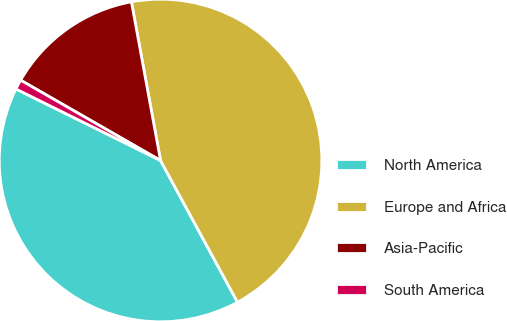<chart> <loc_0><loc_0><loc_500><loc_500><pie_chart><fcel>North America<fcel>Europe and Africa<fcel>Asia-Pacific<fcel>South America<nl><fcel>40.23%<fcel>44.97%<fcel>13.82%<fcel>0.98%<nl></chart> 